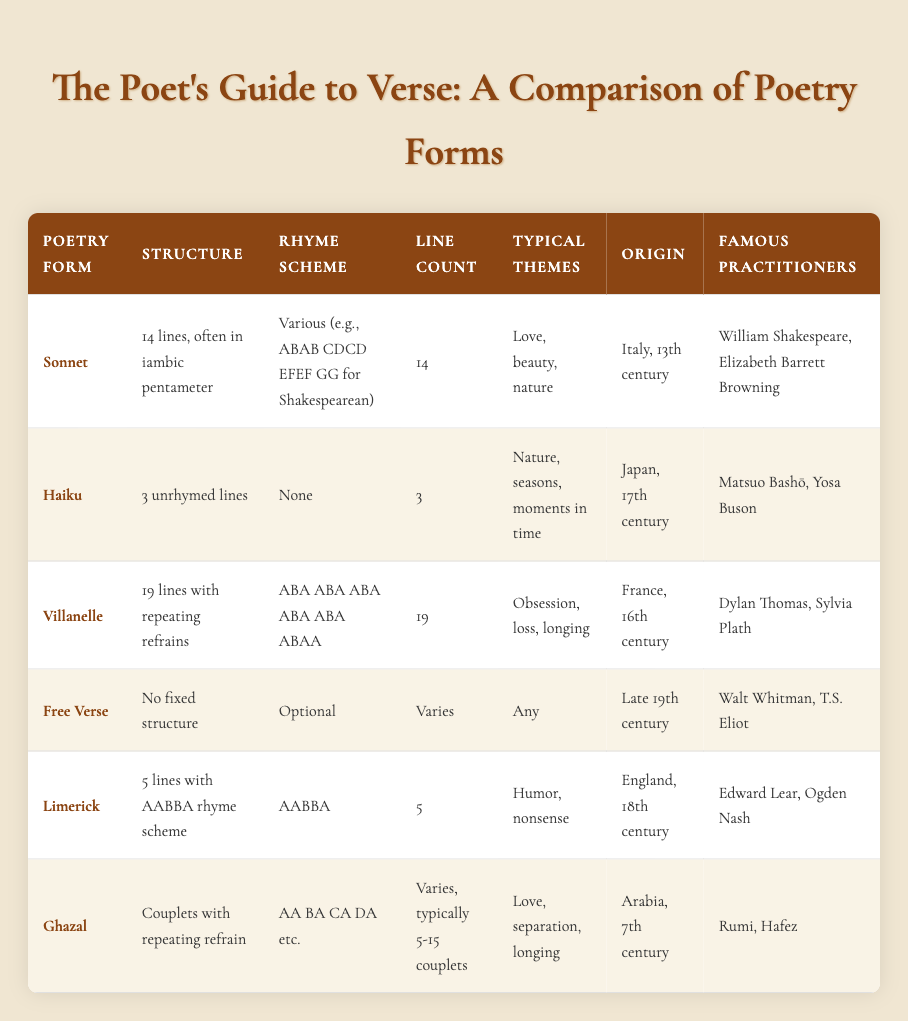What is the structure of a sonnet? The table lists that a sonnet has a structure of 14 lines, often in iambic pentameter.
Answer: 14 lines, often in iambic pentameter Who are the famous practitioners of Haiku? According to the table, the famous practitioners of Haiku are Matsuo Bashō and Yosa Buson.
Answer: Matsuo Bashō, Yosa Buson Is it true that a Villanelle has a fixed structure? The table indicates that a Villanelle has a structure of 19 lines with repeating refrains, meaning it is indeed structured.
Answer: Yes How many typical themes does a Limerick have, and what are they? The table specifies that a Limerick typically focuses on themes of humor and nonsense, therefore it has two themes.
Answer: Humor, nonsense Which poetry forms have their origin in the 17th century? By reviewing the table, we find that the Haiku originated in Japan in the 17th century.
Answer: Haiku What is the difference in line count between a Ghazal and a Limerick? The line count for a Ghazal varies but typically ranges from 5-15 couplets, whereas a Limerick has a fixed line count of 5. Therefore, we cannot provide a numeric difference but identify that a Ghazal can have more lines.
Answer: Ghazal has typically more lines What is the rhyme scheme used in a Free Verse poem? The table notes that Free Verse has an optional rhyme scheme, which means it does not adhere to any specific pattern.
Answer: Optional Name two famous practitioners of the Sonnet form and the country of origin of the Villanelle. The table shows that famous practitioners of the Sonnet include William Shakespeare and Elizabeth Barrett Browning, while the Villanelle originated in France.
Answer: William Shakespeare, Elizabeth Barrett Browning; France How would you characterize the themes of the Ghazal compared to the Sonnet? The table lists that Ghazals typically explore themes of love, separation, and longing, while Sonnets often focus on love, beauty, and nature. Thus, both forms deal with love but differ in their extra themes.
Answer: Both explore love; Ghazal also includes separation and longing 